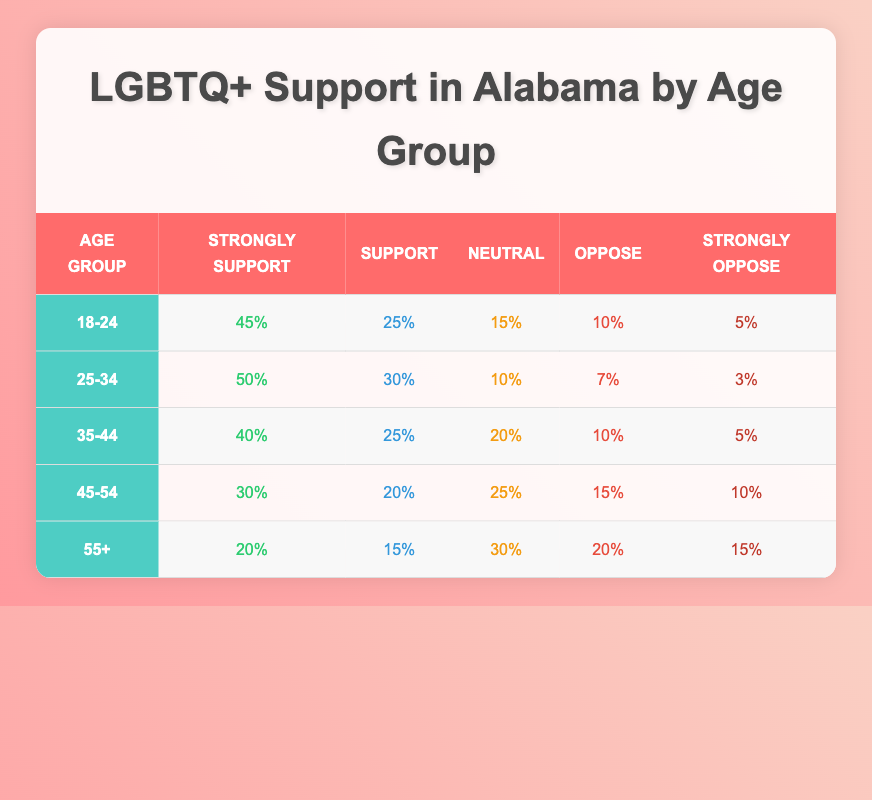What percentage of individuals aged 18-24 strongly support LGBTQ+ rights? According to the table, 45% of individuals in the age group 18-24 strongly support LGBTQ+ rights.
Answer: 45% Which age group has the highest percentage of support for LGBTQ+ rights? The age group 25-34 shows the highest percentage of support at 50%, as indicated in the table.
Answer: 25-34 What is the neutral support percentage for the 45-54 age group? The table states that the neutral support percentage for the 45-54 age group is 25%.
Answer: 25% If you add up the "Oppose" percentages across all age groups, what is the total? The opposition percentages are 10% (18-24) + 7% (25-34) + 10% (35-44) + 15% (45-54) + 20% (55+) = 62%.
Answer: 62% Is it true that more than half of the 55+ age group supports LGBTQ+ rights? In the 55+ age group, only 15% support LGBTQ+ rights, which is not more than half. Therefore, the statement is false.
Answer: No What is the difference in percentage between Strongly Support of the 18-24 and 45-54 age groups? The Strongly Support percentage for the 18-24 age group is 45%, and for the 45-54 age group, it is 30%. The difference is 45% - 30% = 15%.
Answer: 15% What percentage of individuals aged 35-44 either strongly support or support LGBTQ+ rights? Combining the Strongly Support (40%) and Support (25%) percentages gives a total of 65% for the age group 35-44.
Answer: 65% Which age group has the largest percentage opposing LGBTQ+ rights? The 55+ age group has the largest percentage opposing LGBTQ+ rights, at 20%, as shown in the table.
Answer: 55+ 